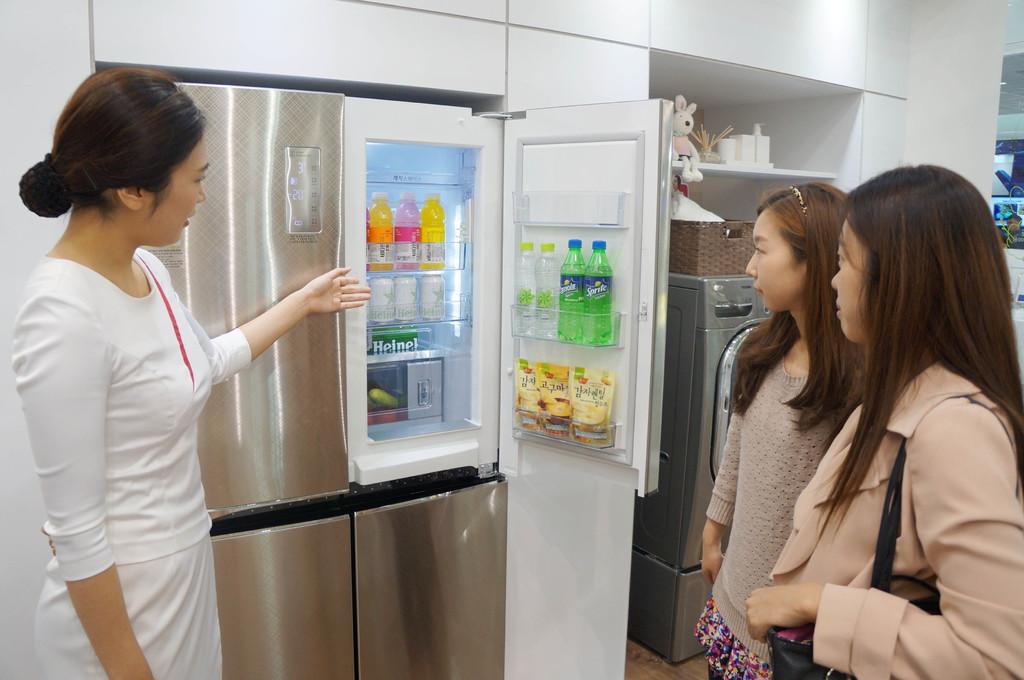What soda is in the green bottle?
Make the answer very short. Sprite. 